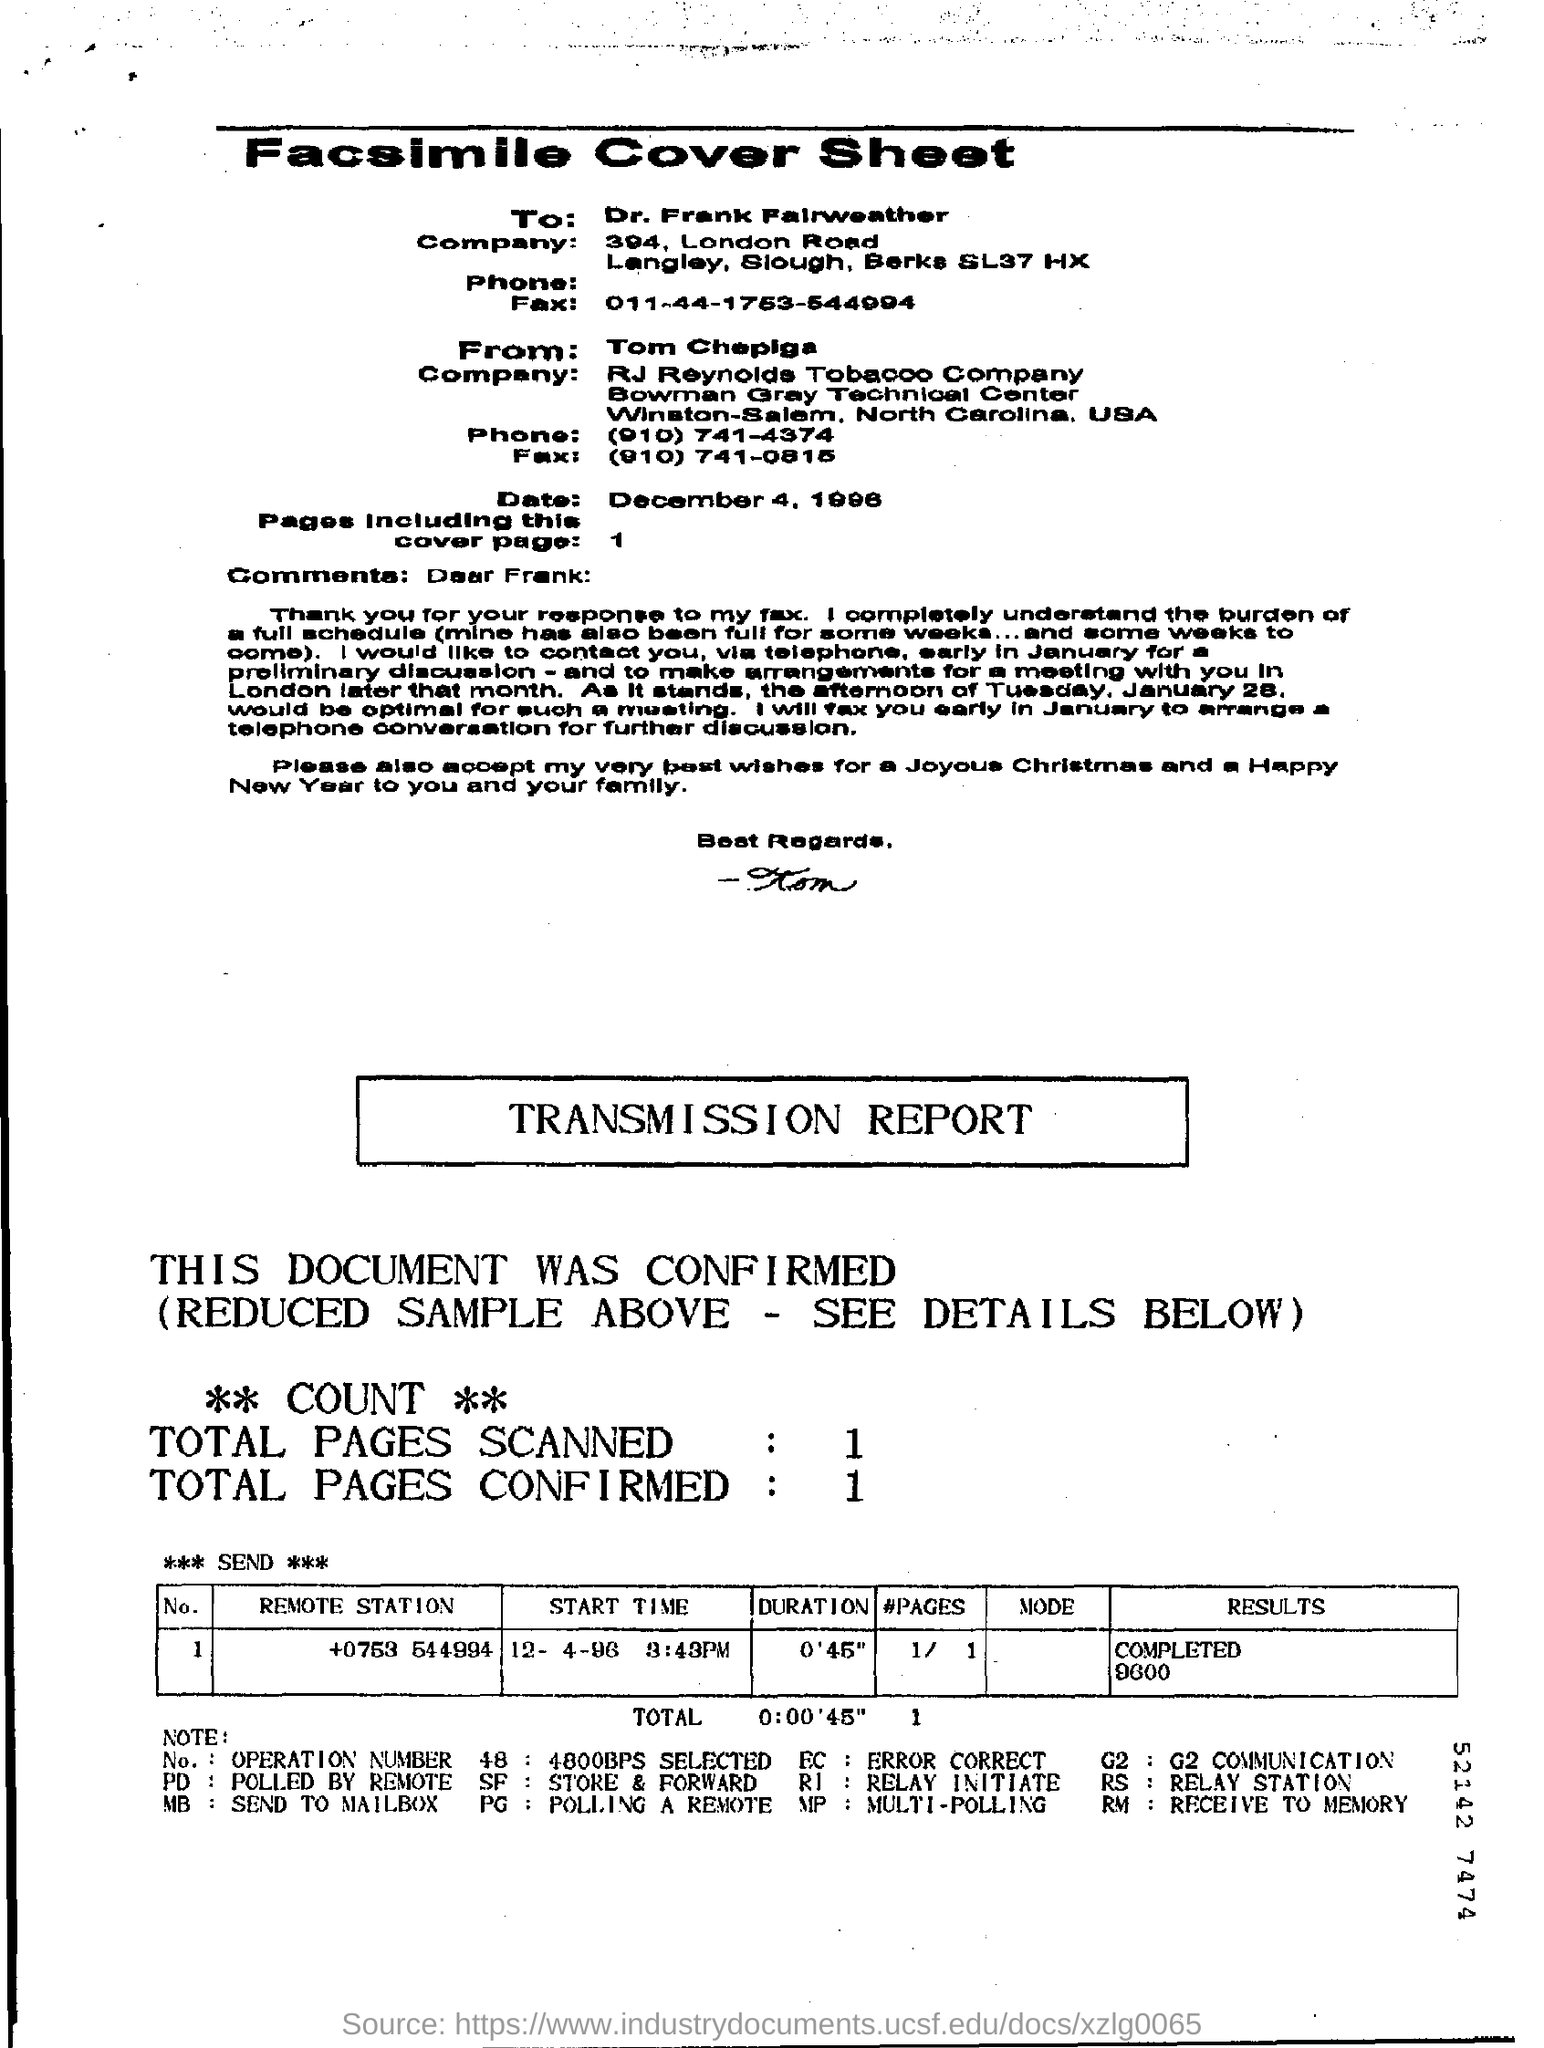List a handful of essential elements in this visual. The recipient of this fax is Dr. Frank Fairweather. The date is December 4, 1996. 